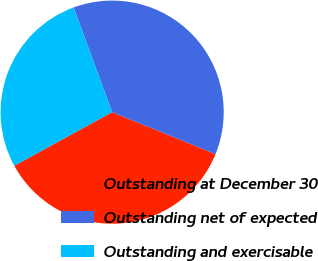Convert chart. <chart><loc_0><loc_0><loc_500><loc_500><pie_chart><fcel>Outstanding at December 30<fcel>Outstanding net of expected<fcel>Outstanding and exercisable<nl><fcel>35.89%<fcel>36.76%<fcel>27.35%<nl></chart> 